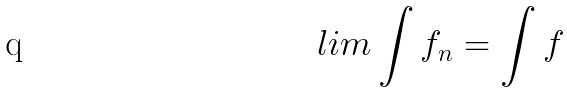Convert formula to latex. <formula><loc_0><loc_0><loc_500><loc_500>l i m \int f _ { n } = \int f</formula> 